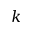Convert formula to latex. <formula><loc_0><loc_0><loc_500><loc_500>k</formula> 